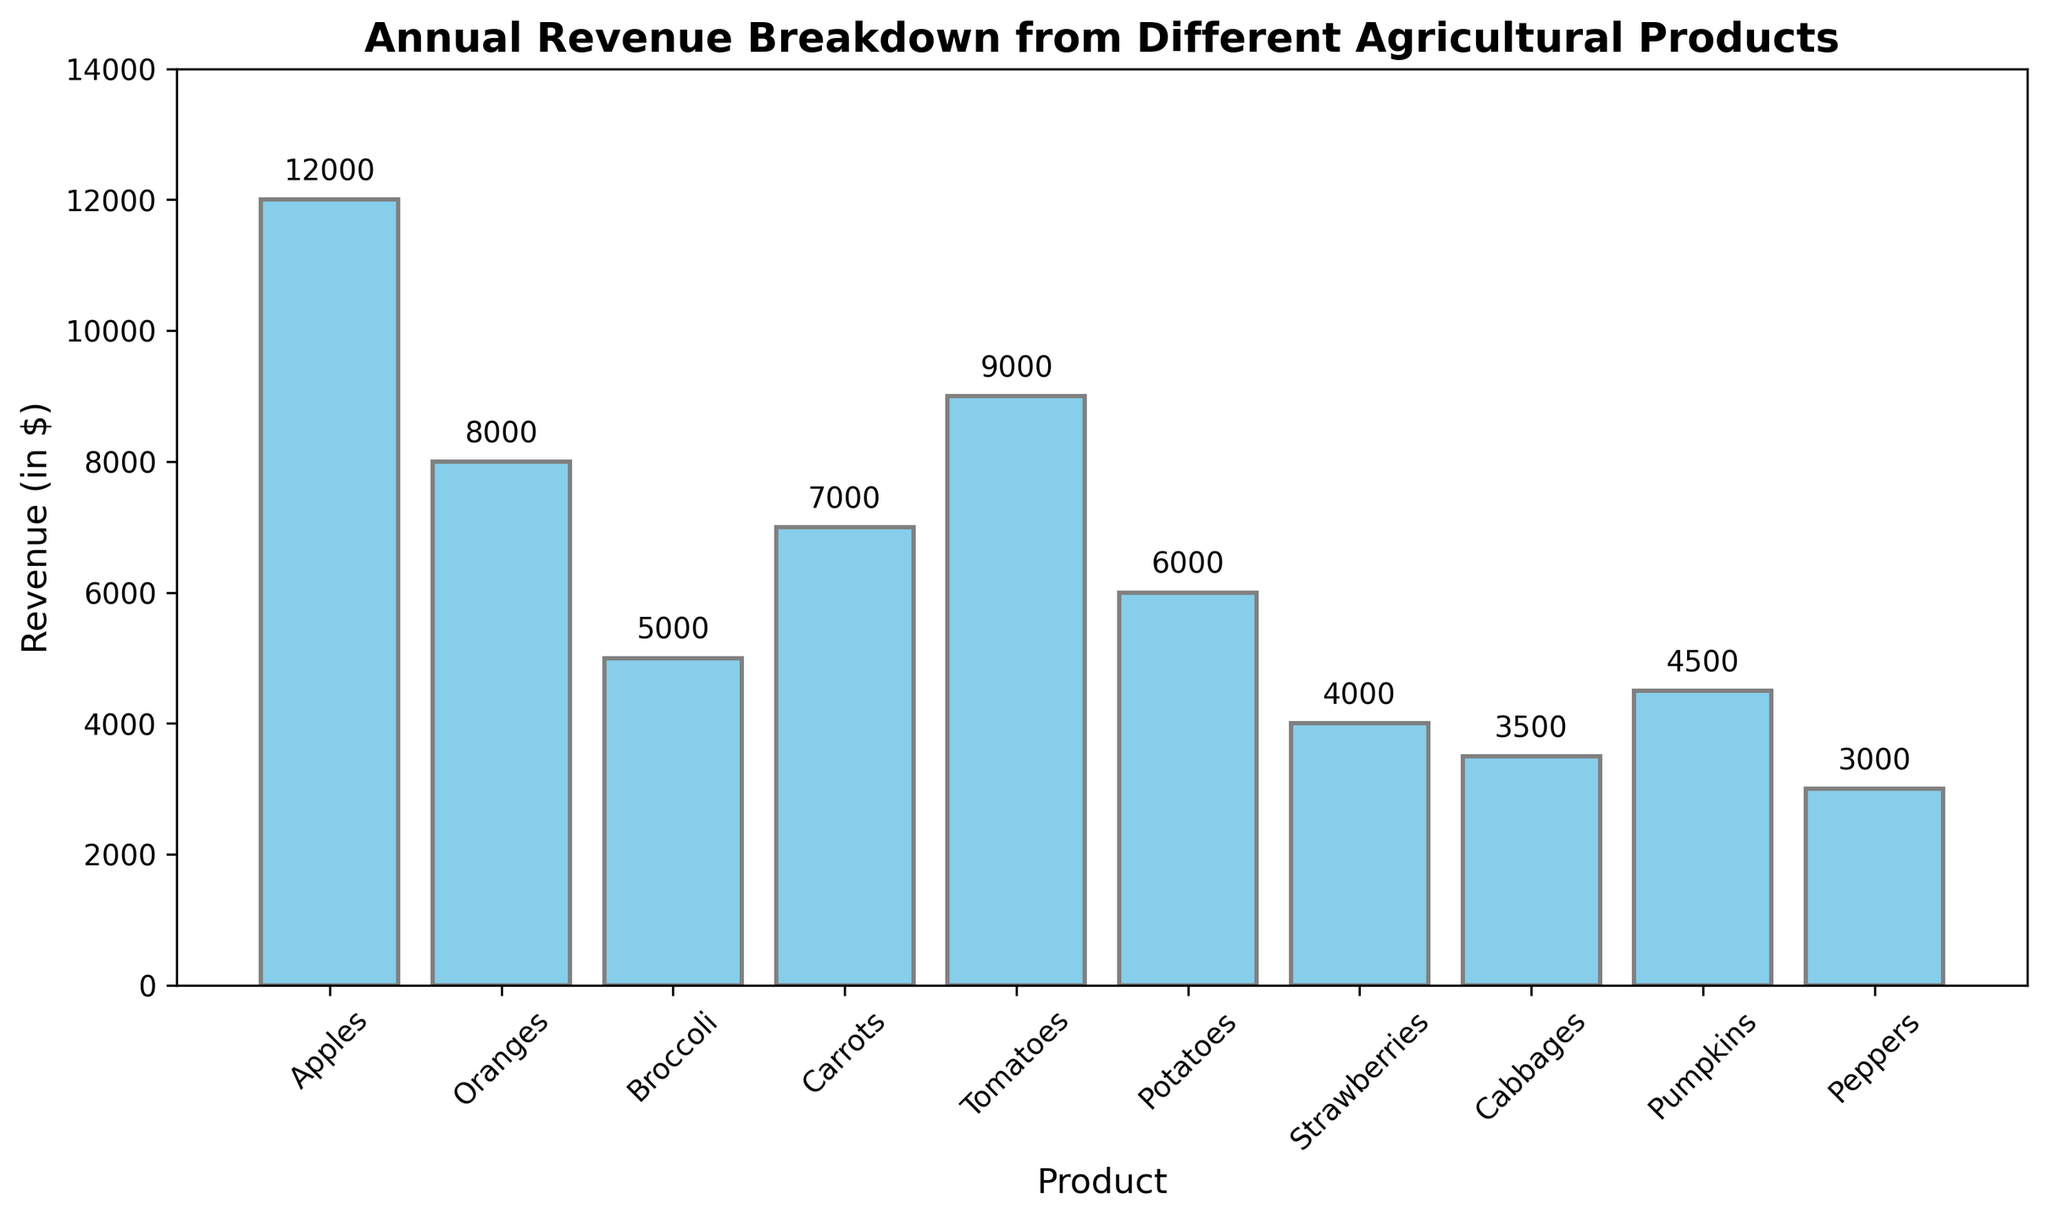Which agricultural product generates the highest revenue? By checking the heights of the bars in the figure, the highest bar represents the product with the highest revenue. Apples have the tallest bar.
Answer: Apples What is the total revenue generated by all the products combined? To find the total revenue, sum up the revenue values for all the products: 12000 (Apples) + 8000 (Oranges) + 5000 (Broccoli) + 7000 (Carrots) + 9000 (Tomatoes) + 6000 (Potatoes) + 4000 (Strawberries) + 3500 (Cabbages) + 4500 (Pumpkins) + 3000 (Peppers) = 60000.
Answer: 60000 Which product generates more revenue, Carrots or Tomatoes, and by how much? Compare the heights of the bars for Carrots and Tomatoes. The revenue for Carrots is 7000 and for Tomatoes is 9000. Subtract the revenue of Carrots from Tomatoes: 9000 - 7000 = 2000.
Answer: Tomatoes, 2000 What is the average revenue generated by the top three revenue-generating products? Identify the top three products by their bar heights: Apples (12000), Tomatoes (9000), and Oranges (8000). Calculate their average by summing and dividing by 3: (12000 + 9000 + 8000)/3 = 29000/3 ≈ 9666.67.
Answer: 9666.67 Are there more products with revenue above 6000 or below 6000? Count the bars with heights above and below 6000: Above 6000 - 5 (Apples, Oranges, Carrots, Tomatoes, Potatoes); Below 6000 - 5 (Broccoli, Strawberries, Cabbages, Pumpkins, Peppers).
Answer: Equal Which product contributes the least to total revenue and what percentage of the total revenue does it represent? Identify the product with the shortest bar, which is Peppers with $3000. Calculate its percentage of the total revenue: (3000 / 60000) * 100 ≈ 5%.
Answer: Peppers, 5% How much more revenue do Apples generate compared to the total revenue generated by Cabbages and Peppers? Apples generate $12000. Sum the revenue of Cabbages and Peppers: 3500 + 3000 = 6500. Subtract the latter total from Apples' revenue: 12000 - 6500 = 5500.
Answer: 5500 What is the difference in revenue between the product with the second-highest revenue and the product with the second-lowest revenue? The second-highest revenue is Tomatoes with $9000, and the second-lowest revenue is Cabbages with $3500. Find the difference: 9000 - 3500 = 5500.
Answer: 5500 How does the revenue from Strawberries compare to the average revenue generated by all products? First, calculate the average revenue: 60000 total / 10 products = 6000. Strawberries generate $4000. Compare $4000 to $6000: Strawberries generate $2000 less than the average.
Answer: 2000 less 